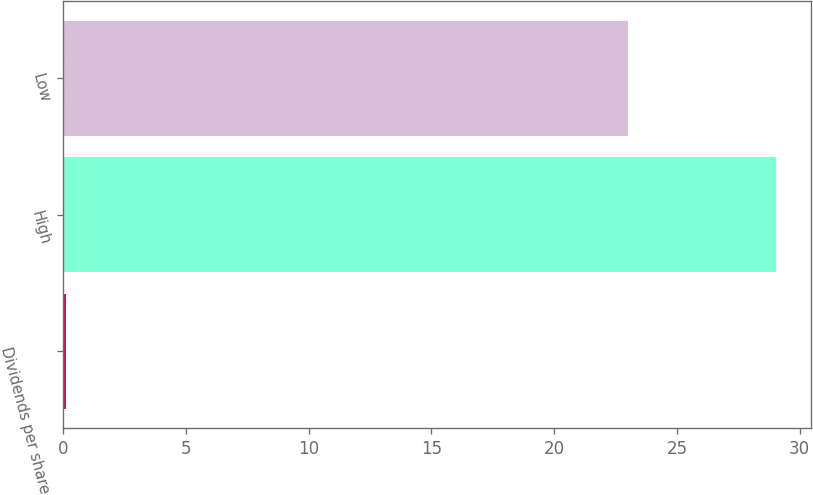<chart> <loc_0><loc_0><loc_500><loc_500><bar_chart><fcel>Dividends per share<fcel>High<fcel>Low<nl><fcel>0.13<fcel>29.02<fcel>23.01<nl></chart> 